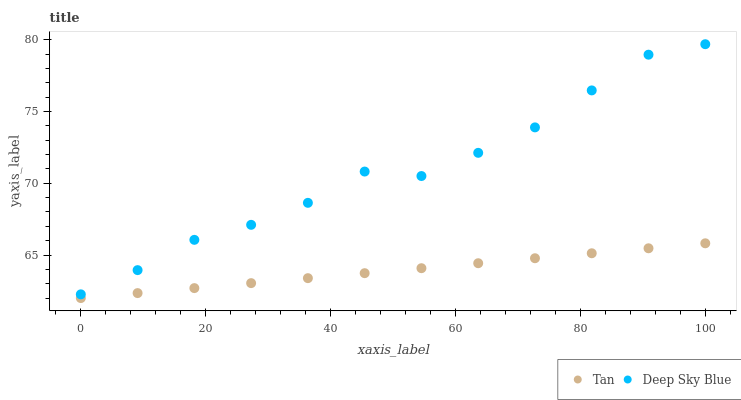Does Tan have the minimum area under the curve?
Answer yes or no. Yes. Does Deep Sky Blue have the maximum area under the curve?
Answer yes or no. Yes. Does Deep Sky Blue have the minimum area under the curve?
Answer yes or no. No. Is Tan the smoothest?
Answer yes or no. Yes. Is Deep Sky Blue the roughest?
Answer yes or no. Yes. Is Deep Sky Blue the smoothest?
Answer yes or no. No. Does Tan have the lowest value?
Answer yes or no. Yes. Does Deep Sky Blue have the lowest value?
Answer yes or no. No. Does Deep Sky Blue have the highest value?
Answer yes or no. Yes. Is Tan less than Deep Sky Blue?
Answer yes or no. Yes. Is Deep Sky Blue greater than Tan?
Answer yes or no. Yes. Does Tan intersect Deep Sky Blue?
Answer yes or no. No. 